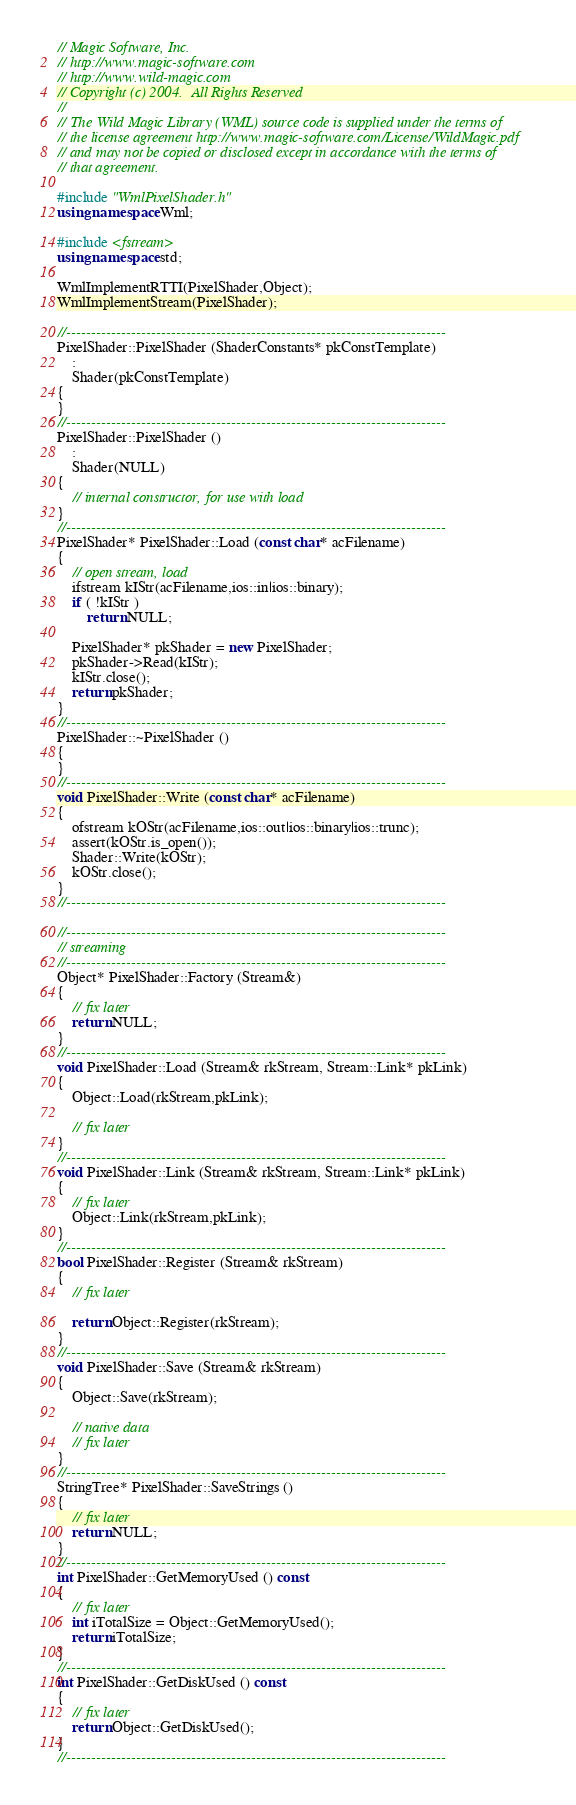<code> <loc_0><loc_0><loc_500><loc_500><_C++_>// Magic Software, Inc.
// http://www.magic-software.com
// http://www.wild-magic.com
// Copyright (c) 2004.  All Rights Reserved
//
// The Wild Magic Library (WML) source code is supplied under the terms of
// the license agreement http://www.magic-software.com/License/WildMagic.pdf
// and may not be copied or disclosed except in accordance with the terms of
// that agreement.

#include "WmlPixelShader.h"
using namespace Wml;

#include <fstream>
using namespace std;

WmlImplementRTTI(PixelShader,Object);
WmlImplementStream(PixelShader);

//----------------------------------------------------------------------------
PixelShader::PixelShader (ShaderConstants* pkConstTemplate)
    :
    Shader(pkConstTemplate)
{
}
//----------------------------------------------------------------------------
PixelShader::PixelShader ()
    :
    Shader(NULL)
{
    // internal constructor, for use with load
}
//----------------------------------------------------------------------------
PixelShader* PixelShader::Load (const char* acFilename)
{
    // open stream, load
    ifstream kIStr(acFilename,ios::in|ios::binary);
    if ( !kIStr )
        return NULL;

    PixelShader* pkShader = new PixelShader;
    pkShader->Read(kIStr);
    kIStr.close();
    return pkShader;
}
//----------------------------------------------------------------------------
PixelShader::~PixelShader ()
{
}
//----------------------------------------------------------------------------
void PixelShader::Write (const char* acFilename)
{
    ofstream kOStr(acFilename,ios::out|ios::binary|ios::trunc);
    assert(kOStr.is_open());
    Shader::Write(kOStr);
    kOStr.close();
}
//----------------------------------------------------------------------------

//----------------------------------------------------------------------------
// streaming
//----------------------------------------------------------------------------
Object* PixelShader::Factory (Stream&)
{
    // fix later
    return NULL;
}
//----------------------------------------------------------------------------
void PixelShader::Load (Stream& rkStream, Stream::Link* pkLink)
{
    Object::Load(rkStream,pkLink);

    // fix later
}
//----------------------------------------------------------------------------
void PixelShader::Link (Stream& rkStream, Stream::Link* pkLink)
{
    // fix later
    Object::Link(rkStream,pkLink);
}
//----------------------------------------------------------------------------
bool PixelShader::Register (Stream& rkStream)
{
    // fix later

    return Object::Register(rkStream);
}
//----------------------------------------------------------------------------
void PixelShader::Save (Stream& rkStream)
{
    Object::Save(rkStream);

    // native data
    // fix later
}
//----------------------------------------------------------------------------
StringTree* PixelShader::SaveStrings ()
{
    // fix later
    return NULL;
}
//----------------------------------------------------------------------------
int PixelShader::GetMemoryUsed () const
{
    // fix later
    int iTotalSize = Object::GetMemoryUsed();
    return iTotalSize;
}
//----------------------------------------------------------------------------
int PixelShader::GetDiskUsed () const
{
    // fix later
    return Object::GetDiskUsed();
}
//----------------------------------------------------------------------------
</code> 